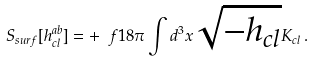<formula> <loc_0><loc_0><loc_500><loc_500>S _ { s u r f } [ h ^ { a b } _ { c l } ] = + \ f { 1 } { 8 \pi } \int d ^ { 3 } x \sqrt { - h _ { c l } } K _ { c l } \, .</formula> 